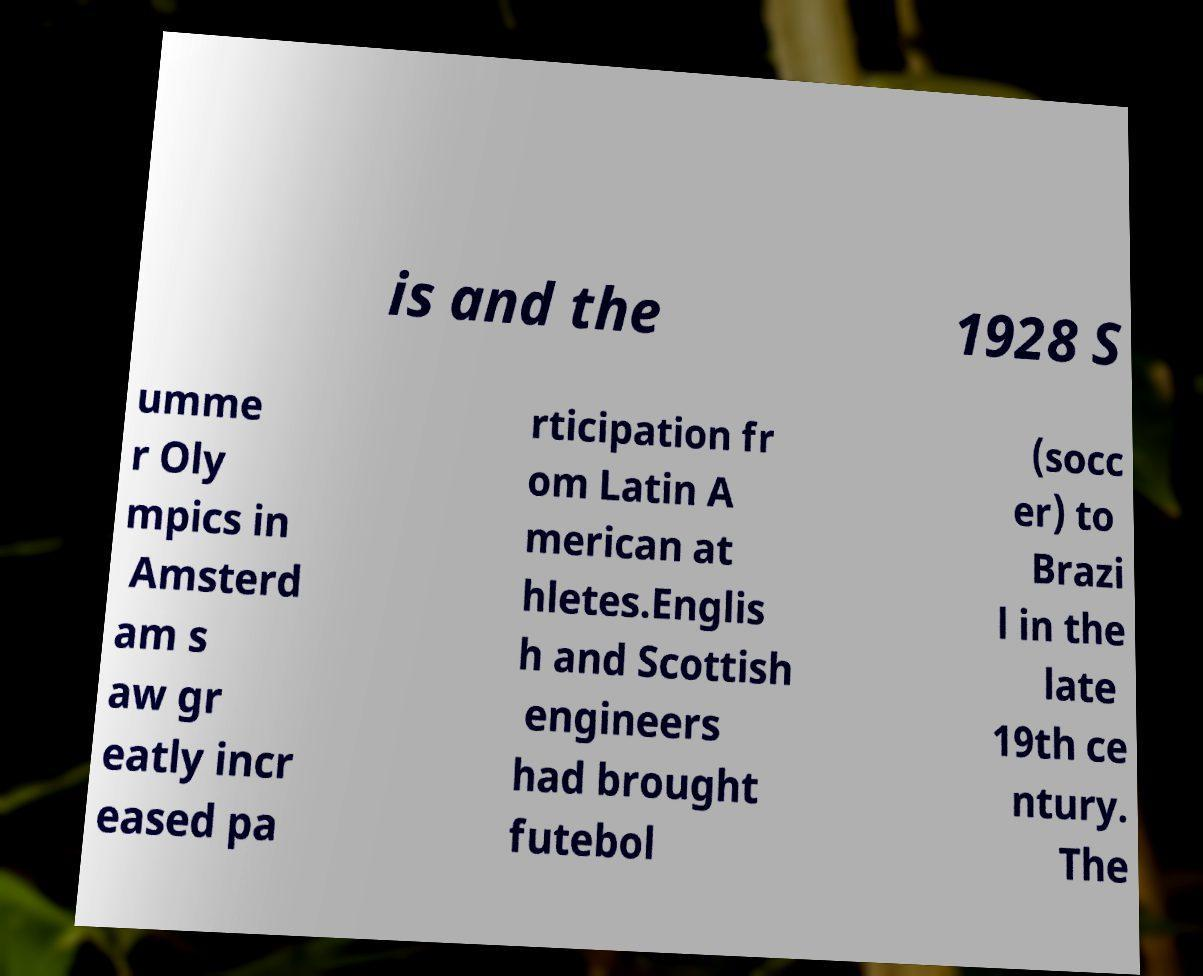Could you extract and type out the text from this image? is and the 1928 S umme r Oly mpics in Amsterd am s aw gr eatly incr eased pa rticipation fr om Latin A merican at hletes.Englis h and Scottish engineers had brought futebol (socc er) to Brazi l in the late 19th ce ntury. The 